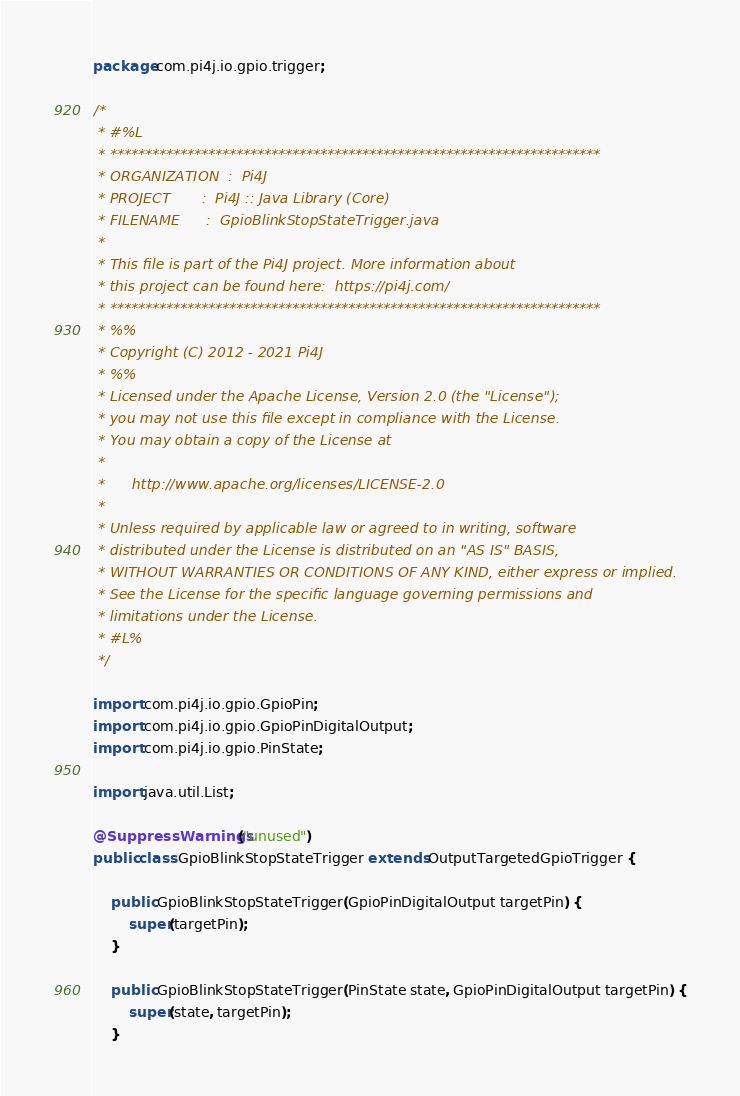Convert code to text. <code><loc_0><loc_0><loc_500><loc_500><_Java_>package com.pi4j.io.gpio.trigger;

/*
 * #%L
 * **********************************************************************
 * ORGANIZATION  :  Pi4J
 * PROJECT       :  Pi4J :: Java Library (Core)
 * FILENAME      :  GpioBlinkStopStateTrigger.java
 *
 * This file is part of the Pi4J project. More information about
 * this project can be found here:  https://pi4j.com/
 * **********************************************************************
 * %%
 * Copyright (C) 2012 - 2021 Pi4J
 * %%
 * Licensed under the Apache License, Version 2.0 (the "License");
 * you may not use this file except in compliance with the License.
 * You may obtain a copy of the License at
 *
 *      http://www.apache.org/licenses/LICENSE-2.0
 *
 * Unless required by applicable law or agreed to in writing, software
 * distributed under the License is distributed on an "AS IS" BASIS,
 * WITHOUT WARRANTIES OR CONDITIONS OF ANY KIND, either express or implied.
 * See the License for the specific language governing permissions and
 * limitations under the License.
 * #L%
 */

import com.pi4j.io.gpio.GpioPin;
import com.pi4j.io.gpio.GpioPinDigitalOutput;
import com.pi4j.io.gpio.PinState;

import java.util.List;

@SuppressWarnings("unused")
public class GpioBlinkStopStateTrigger extends OutputTargetedGpioTrigger {

	public GpioBlinkStopStateTrigger(GpioPinDigitalOutput targetPin) {
		super(targetPin);
	}

	public GpioBlinkStopStateTrigger(PinState state, GpioPinDigitalOutput targetPin) {
		super(state, targetPin);
	}
</code> 